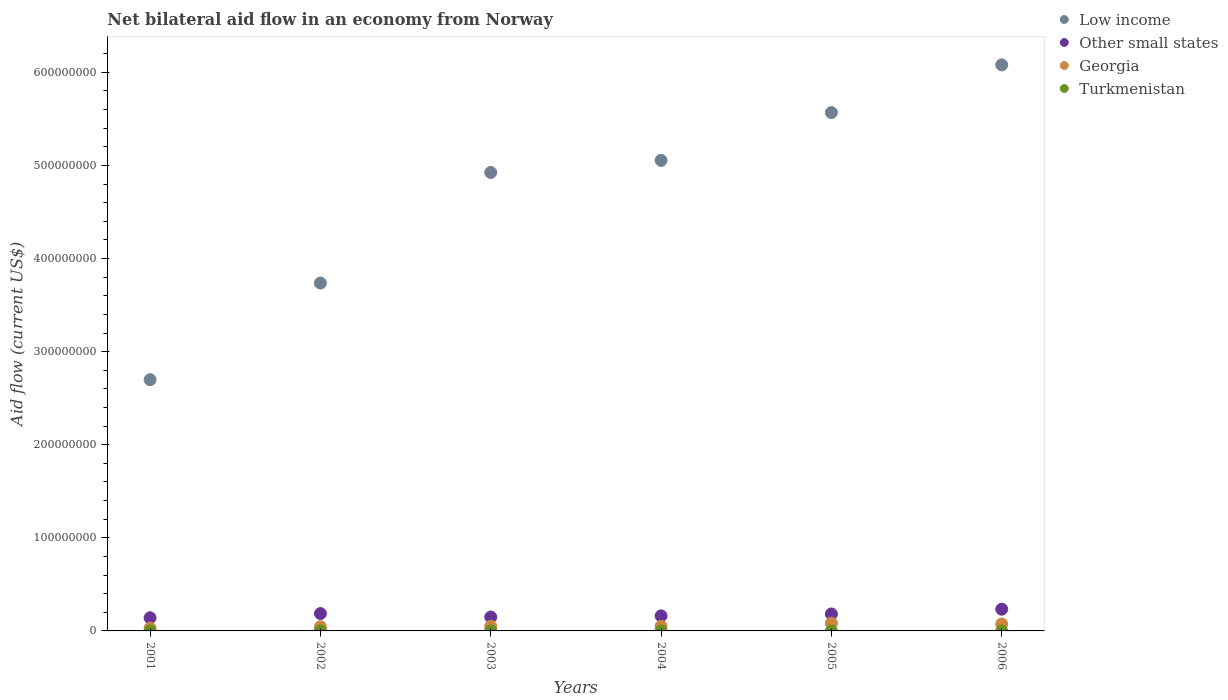How many different coloured dotlines are there?
Your response must be concise. 4. What is the net bilateral aid flow in Low income in 2001?
Provide a short and direct response. 2.70e+08. Across all years, what is the maximum net bilateral aid flow in Other small states?
Offer a very short reply. 2.33e+07. Across all years, what is the minimum net bilateral aid flow in Georgia?
Give a very brief answer. 3.11e+06. In which year was the net bilateral aid flow in Georgia maximum?
Your response must be concise. 2005. What is the total net bilateral aid flow in Georgia in the graph?
Your answer should be compact. 3.32e+07. What is the difference between the net bilateral aid flow in Georgia in 2001 and that in 2002?
Your answer should be very brief. -1.33e+06. What is the difference between the net bilateral aid flow in Other small states in 2002 and the net bilateral aid flow in Georgia in 2001?
Your response must be concise. 1.56e+07. What is the average net bilateral aid flow in Other small states per year?
Make the answer very short. 1.76e+07. In the year 2005, what is the difference between the net bilateral aid flow in Turkmenistan and net bilateral aid flow in Low income?
Your answer should be compact. -5.57e+08. What is the ratio of the net bilateral aid flow in Turkmenistan in 2001 to that in 2002?
Provide a short and direct response. 0.2. What is the difference between the highest and the second highest net bilateral aid flow in Low income?
Keep it short and to the point. 5.12e+07. What is the difference between the highest and the lowest net bilateral aid flow in Other small states?
Make the answer very short. 9.19e+06. Is the sum of the net bilateral aid flow in Georgia in 2004 and 2005 greater than the maximum net bilateral aid flow in Low income across all years?
Offer a terse response. No. Is it the case that in every year, the sum of the net bilateral aid flow in Georgia and net bilateral aid flow in Low income  is greater than the sum of net bilateral aid flow in Turkmenistan and net bilateral aid flow in Other small states?
Your answer should be compact. No. Does the net bilateral aid flow in Georgia monotonically increase over the years?
Give a very brief answer. No. Is the net bilateral aid flow in Georgia strictly less than the net bilateral aid flow in Low income over the years?
Provide a succinct answer. Yes. How many dotlines are there?
Provide a succinct answer. 4. How many years are there in the graph?
Keep it short and to the point. 6. Are the values on the major ticks of Y-axis written in scientific E-notation?
Give a very brief answer. No. Does the graph contain grids?
Provide a succinct answer. No. Where does the legend appear in the graph?
Your response must be concise. Top right. How many legend labels are there?
Offer a very short reply. 4. What is the title of the graph?
Keep it short and to the point. Net bilateral aid flow in an economy from Norway. Does "St. Vincent and the Grenadines" appear as one of the legend labels in the graph?
Offer a very short reply. No. What is the Aid flow (current US$) in Low income in 2001?
Offer a terse response. 2.70e+08. What is the Aid flow (current US$) in Other small states in 2001?
Provide a short and direct response. 1.41e+07. What is the Aid flow (current US$) in Georgia in 2001?
Ensure brevity in your answer.  3.11e+06. What is the Aid flow (current US$) in Low income in 2002?
Offer a terse response. 3.74e+08. What is the Aid flow (current US$) in Other small states in 2002?
Make the answer very short. 1.87e+07. What is the Aid flow (current US$) in Georgia in 2002?
Your answer should be compact. 4.44e+06. What is the Aid flow (current US$) of Low income in 2003?
Offer a terse response. 4.92e+08. What is the Aid flow (current US$) of Other small states in 2003?
Keep it short and to the point. 1.49e+07. What is the Aid flow (current US$) in Georgia in 2003?
Your response must be concise. 5.02e+06. What is the Aid flow (current US$) of Turkmenistan in 2003?
Ensure brevity in your answer.  1.40e+05. What is the Aid flow (current US$) in Low income in 2004?
Give a very brief answer. 5.05e+08. What is the Aid flow (current US$) in Other small states in 2004?
Give a very brief answer. 1.62e+07. What is the Aid flow (current US$) of Georgia in 2004?
Provide a succinct answer. 4.84e+06. What is the Aid flow (current US$) in Low income in 2005?
Your response must be concise. 5.57e+08. What is the Aid flow (current US$) of Other small states in 2005?
Keep it short and to the point. 1.82e+07. What is the Aid flow (current US$) in Georgia in 2005?
Give a very brief answer. 8.37e+06. What is the Aid flow (current US$) in Low income in 2006?
Keep it short and to the point. 6.08e+08. What is the Aid flow (current US$) in Other small states in 2006?
Offer a terse response. 2.33e+07. What is the Aid flow (current US$) of Georgia in 2006?
Your answer should be very brief. 7.42e+06. What is the Aid flow (current US$) of Turkmenistan in 2006?
Your answer should be very brief. 3.00e+04. Across all years, what is the maximum Aid flow (current US$) of Low income?
Keep it short and to the point. 6.08e+08. Across all years, what is the maximum Aid flow (current US$) in Other small states?
Your answer should be very brief. 2.33e+07. Across all years, what is the maximum Aid flow (current US$) of Georgia?
Your response must be concise. 8.37e+06. Across all years, what is the maximum Aid flow (current US$) in Turkmenistan?
Offer a very short reply. 2.00e+05. Across all years, what is the minimum Aid flow (current US$) of Low income?
Ensure brevity in your answer.  2.70e+08. Across all years, what is the minimum Aid flow (current US$) in Other small states?
Keep it short and to the point. 1.41e+07. Across all years, what is the minimum Aid flow (current US$) in Georgia?
Give a very brief answer. 3.11e+06. Across all years, what is the minimum Aid flow (current US$) of Turkmenistan?
Your answer should be very brief. 2.00e+04. What is the total Aid flow (current US$) in Low income in the graph?
Give a very brief answer. 2.81e+09. What is the total Aid flow (current US$) in Other small states in the graph?
Keep it short and to the point. 1.05e+08. What is the total Aid flow (current US$) in Georgia in the graph?
Your answer should be very brief. 3.32e+07. What is the total Aid flow (current US$) in Turkmenistan in the graph?
Your answer should be compact. 5.60e+05. What is the difference between the Aid flow (current US$) of Low income in 2001 and that in 2002?
Your answer should be compact. -1.04e+08. What is the difference between the Aid flow (current US$) of Other small states in 2001 and that in 2002?
Provide a short and direct response. -4.52e+06. What is the difference between the Aid flow (current US$) in Georgia in 2001 and that in 2002?
Your response must be concise. -1.33e+06. What is the difference between the Aid flow (current US$) of Turkmenistan in 2001 and that in 2002?
Offer a very short reply. -1.60e+05. What is the difference between the Aid flow (current US$) in Low income in 2001 and that in 2003?
Give a very brief answer. -2.23e+08. What is the difference between the Aid flow (current US$) in Other small states in 2001 and that in 2003?
Keep it short and to the point. -8.00e+05. What is the difference between the Aid flow (current US$) in Georgia in 2001 and that in 2003?
Offer a terse response. -1.91e+06. What is the difference between the Aid flow (current US$) in Low income in 2001 and that in 2004?
Offer a terse response. -2.36e+08. What is the difference between the Aid flow (current US$) in Other small states in 2001 and that in 2004?
Your answer should be very brief. -2.05e+06. What is the difference between the Aid flow (current US$) in Georgia in 2001 and that in 2004?
Give a very brief answer. -1.73e+06. What is the difference between the Aid flow (current US$) in Low income in 2001 and that in 2005?
Your response must be concise. -2.87e+08. What is the difference between the Aid flow (current US$) of Other small states in 2001 and that in 2005?
Ensure brevity in your answer.  -4.08e+06. What is the difference between the Aid flow (current US$) in Georgia in 2001 and that in 2005?
Your answer should be compact. -5.26e+06. What is the difference between the Aid flow (current US$) in Low income in 2001 and that in 2006?
Keep it short and to the point. -3.38e+08. What is the difference between the Aid flow (current US$) of Other small states in 2001 and that in 2006?
Give a very brief answer. -9.19e+06. What is the difference between the Aid flow (current US$) in Georgia in 2001 and that in 2006?
Your response must be concise. -4.31e+06. What is the difference between the Aid flow (current US$) in Turkmenistan in 2001 and that in 2006?
Keep it short and to the point. 10000. What is the difference between the Aid flow (current US$) of Low income in 2002 and that in 2003?
Your response must be concise. -1.19e+08. What is the difference between the Aid flow (current US$) in Other small states in 2002 and that in 2003?
Make the answer very short. 3.72e+06. What is the difference between the Aid flow (current US$) in Georgia in 2002 and that in 2003?
Ensure brevity in your answer.  -5.80e+05. What is the difference between the Aid flow (current US$) of Turkmenistan in 2002 and that in 2003?
Offer a very short reply. 6.00e+04. What is the difference between the Aid flow (current US$) of Low income in 2002 and that in 2004?
Your response must be concise. -1.32e+08. What is the difference between the Aid flow (current US$) in Other small states in 2002 and that in 2004?
Give a very brief answer. 2.47e+06. What is the difference between the Aid flow (current US$) of Georgia in 2002 and that in 2004?
Provide a short and direct response. -4.00e+05. What is the difference between the Aid flow (current US$) of Low income in 2002 and that in 2005?
Your answer should be very brief. -1.83e+08. What is the difference between the Aid flow (current US$) in Georgia in 2002 and that in 2005?
Offer a terse response. -3.93e+06. What is the difference between the Aid flow (current US$) of Turkmenistan in 2002 and that in 2005?
Your answer should be very brief. 1.80e+05. What is the difference between the Aid flow (current US$) of Low income in 2002 and that in 2006?
Your response must be concise. -2.34e+08. What is the difference between the Aid flow (current US$) of Other small states in 2002 and that in 2006?
Offer a very short reply. -4.67e+06. What is the difference between the Aid flow (current US$) of Georgia in 2002 and that in 2006?
Make the answer very short. -2.98e+06. What is the difference between the Aid flow (current US$) of Turkmenistan in 2002 and that in 2006?
Give a very brief answer. 1.70e+05. What is the difference between the Aid flow (current US$) in Low income in 2003 and that in 2004?
Your answer should be compact. -1.30e+07. What is the difference between the Aid flow (current US$) in Other small states in 2003 and that in 2004?
Give a very brief answer. -1.25e+06. What is the difference between the Aid flow (current US$) of Turkmenistan in 2003 and that in 2004?
Give a very brief answer. 10000. What is the difference between the Aid flow (current US$) of Low income in 2003 and that in 2005?
Offer a very short reply. -6.43e+07. What is the difference between the Aid flow (current US$) of Other small states in 2003 and that in 2005?
Keep it short and to the point. -3.28e+06. What is the difference between the Aid flow (current US$) of Georgia in 2003 and that in 2005?
Give a very brief answer. -3.35e+06. What is the difference between the Aid flow (current US$) of Low income in 2003 and that in 2006?
Offer a terse response. -1.16e+08. What is the difference between the Aid flow (current US$) of Other small states in 2003 and that in 2006?
Provide a short and direct response. -8.39e+06. What is the difference between the Aid flow (current US$) in Georgia in 2003 and that in 2006?
Ensure brevity in your answer.  -2.40e+06. What is the difference between the Aid flow (current US$) of Turkmenistan in 2003 and that in 2006?
Your response must be concise. 1.10e+05. What is the difference between the Aid flow (current US$) in Low income in 2004 and that in 2005?
Provide a succinct answer. -5.13e+07. What is the difference between the Aid flow (current US$) in Other small states in 2004 and that in 2005?
Your answer should be compact. -2.03e+06. What is the difference between the Aid flow (current US$) of Georgia in 2004 and that in 2005?
Give a very brief answer. -3.53e+06. What is the difference between the Aid flow (current US$) in Low income in 2004 and that in 2006?
Offer a terse response. -1.03e+08. What is the difference between the Aid flow (current US$) in Other small states in 2004 and that in 2006?
Your answer should be very brief. -7.14e+06. What is the difference between the Aid flow (current US$) in Georgia in 2004 and that in 2006?
Provide a succinct answer. -2.58e+06. What is the difference between the Aid flow (current US$) in Low income in 2005 and that in 2006?
Ensure brevity in your answer.  -5.12e+07. What is the difference between the Aid flow (current US$) of Other small states in 2005 and that in 2006?
Provide a succinct answer. -5.11e+06. What is the difference between the Aid flow (current US$) of Georgia in 2005 and that in 2006?
Offer a very short reply. 9.50e+05. What is the difference between the Aid flow (current US$) of Turkmenistan in 2005 and that in 2006?
Give a very brief answer. -10000. What is the difference between the Aid flow (current US$) of Low income in 2001 and the Aid flow (current US$) of Other small states in 2002?
Keep it short and to the point. 2.51e+08. What is the difference between the Aid flow (current US$) of Low income in 2001 and the Aid flow (current US$) of Georgia in 2002?
Make the answer very short. 2.65e+08. What is the difference between the Aid flow (current US$) of Low income in 2001 and the Aid flow (current US$) of Turkmenistan in 2002?
Offer a very short reply. 2.70e+08. What is the difference between the Aid flow (current US$) in Other small states in 2001 and the Aid flow (current US$) in Georgia in 2002?
Provide a succinct answer. 9.70e+06. What is the difference between the Aid flow (current US$) in Other small states in 2001 and the Aid flow (current US$) in Turkmenistan in 2002?
Give a very brief answer. 1.39e+07. What is the difference between the Aid flow (current US$) in Georgia in 2001 and the Aid flow (current US$) in Turkmenistan in 2002?
Your answer should be compact. 2.91e+06. What is the difference between the Aid flow (current US$) of Low income in 2001 and the Aid flow (current US$) of Other small states in 2003?
Ensure brevity in your answer.  2.55e+08. What is the difference between the Aid flow (current US$) of Low income in 2001 and the Aid flow (current US$) of Georgia in 2003?
Ensure brevity in your answer.  2.65e+08. What is the difference between the Aid flow (current US$) of Low income in 2001 and the Aid flow (current US$) of Turkmenistan in 2003?
Keep it short and to the point. 2.70e+08. What is the difference between the Aid flow (current US$) of Other small states in 2001 and the Aid flow (current US$) of Georgia in 2003?
Provide a short and direct response. 9.12e+06. What is the difference between the Aid flow (current US$) in Other small states in 2001 and the Aid flow (current US$) in Turkmenistan in 2003?
Your answer should be very brief. 1.40e+07. What is the difference between the Aid flow (current US$) of Georgia in 2001 and the Aid flow (current US$) of Turkmenistan in 2003?
Give a very brief answer. 2.97e+06. What is the difference between the Aid flow (current US$) in Low income in 2001 and the Aid flow (current US$) in Other small states in 2004?
Your answer should be compact. 2.54e+08. What is the difference between the Aid flow (current US$) in Low income in 2001 and the Aid flow (current US$) in Georgia in 2004?
Provide a short and direct response. 2.65e+08. What is the difference between the Aid flow (current US$) of Low income in 2001 and the Aid flow (current US$) of Turkmenistan in 2004?
Your response must be concise. 2.70e+08. What is the difference between the Aid flow (current US$) in Other small states in 2001 and the Aid flow (current US$) in Georgia in 2004?
Ensure brevity in your answer.  9.30e+06. What is the difference between the Aid flow (current US$) of Other small states in 2001 and the Aid flow (current US$) of Turkmenistan in 2004?
Ensure brevity in your answer.  1.40e+07. What is the difference between the Aid flow (current US$) of Georgia in 2001 and the Aid flow (current US$) of Turkmenistan in 2004?
Ensure brevity in your answer.  2.98e+06. What is the difference between the Aid flow (current US$) of Low income in 2001 and the Aid flow (current US$) of Other small states in 2005?
Provide a short and direct response. 2.52e+08. What is the difference between the Aid flow (current US$) of Low income in 2001 and the Aid flow (current US$) of Georgia in 2005?
Offer a terse response. 2.62e+08. What is the difference between the Aid flow (current US$) in Low income in 2001 and the Aid flow (current US$) in Turkmenistan in 2005?
Your response must be concise. 2.70e+08. What is the difference between the Aid flow (current US$) of Other small states in 2001 and the Aid flow (current US$) of Georgia in 2005?
Provide a short and direct response. 5.77e+06. What is the difference between the Aid flow (current US$) of Other small states in 2001 and the Aid flow (current US$) of Turkmenistan in 2005?
Your answer should be compact. 1.41e+07. What is the difference between the Aid flow (current US$) in Georgia in 2001 and the Aid flow (current US$) in Turkmenistan in 2005?
Make the answer very short. 3.09e+06. What is the difference between the Aid flow (current US$) in Low income in 2001 and the Aid flow (current US$) in Other small states in 2006?
Provide a succinct answer. 2.47e+08. What is the difference between the Aid flow (current US$) in Low income in 2001 and the Aid flow (current US$) in Georgia in 2006?
Provide a succinct answer. 2.62e+08. What is the difference between the Aid flow (current US$) in Low income in 2001 and the Aid flow (current US$) in Turkmenistan in 2006?
Ensure brevity in your answer.  2.70e+08. What is the difference between the Aid flow (current US$) in Other small states in 2001 and the Aid flow (current US$) in Georgia in 2006?
Your answer should be compact. 6.72e+06. What is the difference between the Aid flow (current US$) of Other small states in 2001 and the Aid flow (current US$) of Turkmenistan in 2006?
Your answer should be very brief. 1.41e+07. What is the difference between the Aid flow (current US$) of Georgia in 2001 and the Aid flow (current US$) of Turkmenistan in 2006?
Your response must be concise. 3.08e+06. What is the difference between the Aid flow (current US$) of Low income in 2002 and the Aid flow (current US$) of Other small states in 2003?
Your response must be concise. 3.59e+08. What is the difference between the Aid flow (current US$) in Low income in 2002 and the Aid flow (current US$) in Georgia in 2003?
Ensure brevity in your answer.  3.69e+08. What is the difference between the Aid flow (current US$) in Low income in 2002 and the Aid flow (current US$) in Turkmenistan in 2003?
Your answer should be very brief. 3.74e+08. What is the difference between the Aid flow (current US$) in Other small states in 2002 and the Aid flow (current US$) in Georgia in 2003?
Your answer should be very brief. 1.36e+07. What is the difference between the Aid flow (current US$) of Other small states in 2002 and the Aid flow (current US$) of Turkmenistan in 2003?
Provide a short and direct response. 1.85e+07. What is the difference between the Aid flow (current US$) in Georgia in 2002 and the Aid flow (current US$) in Turkmenistan in 2003?
Keep it short and to the point. 4.30e+06. What is the difference between the Aid flow (current US$) of Low income in 2002 and the Aid flow (current US$) of Other small states in 2004?
Offer a terse response. 3.57e+08. What is the difference between the Aid flow (current US$) in Low income in 2002 and the Aid flow (current US$) in Georgia in 2004?
Make the answer very short. 3.69e+08. What is the difference between the Aid flow (current US$) of Low income in 2002 and the Aid flow (current US$) of Turkmenistan in 2004?
Your response must be concise. 3.74e+08. What is the difference between the Aid flow (current US$) of Other small states in 2002 and the Aid flow (current US$) of Georgia in 2004?
Your answer should be compact. 1.38e+07. What is the difference between the Aid flow (current US$) of Other small states in 2002 and the Aid flow (current US$) of Turkmenistan in 2004?
Offer a terse response. 1.85e+07. What is the difference between the Aid flow (current US$) in Georgia in 2002 and the Aid flow (current US$) in Turkmenistan in 2004?
Your answer should be compact. 4.31e+06. What is the difference between the Aid flow (current US$) of Low income in 2002 and the Aid flow (current US$) of Other small states in 2005?
Offer a very short reply. 3.55e+08. What is the difference between the Aid flow (current US$) in Low income in 2002 and the Aid flow (current US$) in Georgia in 2005?
Your response must be concise. 3.65e+08. What is the difference between the Aid flow (current US$) of Low income in 2002 and the Aid flow (current US$) of Turkmenistan in 2005?
Your response must be concise. 3.74e+08. What is the difference between the Aid flow (current US$) in Other small states in 2002 and the Aid flow (current US$) in Georgia in 2005?
Give a very brief answer. 1.03e+07. What is the difference between the Aid flow (current US$) in Other small states in 2002 and the Aid flow (current US$) in Turkmenistan in 2005?
Make the answer very short. 1.86e+07. What is the difference between the Aid flow (current US$) in Georgia in 2002 and the Aid flow (current US$) in Turkmenistan in 2005?
Your answer should be very brief. 4.42e+06. What is the difference between the Aid flow (current US$) in Low income in 2002 and the Aid flow (current US$) in Other small states in 2006?
Make the answer very short. 3.50e+08. What is the difference between the Aid flow (current US$) of Low income in 2002 and the Aid flow (current US$) of Georgia in 2006?
Keep it short and to the point. 3.66e+08. What is the difference between the Aid flow (current US$) in Low income in 2002 and the Aid flow (current US$) in Turkmenistan in 2006?
Offer a terse response. 3.74e+08. What is the difference between the Aid flow (current US$) in Other small states in 2002 and the Aid flow (current US$) in Georgia in 2006?
Offer a terse response. 1.12e+07. What is the difference between the Aid flow (current US$) of Other small states in 2002 and the Aid flow (current US$) of Turkmenistan in 2006?
Your answer should be very brief. 1.86e+07. What is the difference between the Aid flow (current US$) of Georgia in 2002 and the Aid flow (current US$) of Turkmenistan in 2006?
Your answer should be very brief. 4.41e+06. What is the difference between the Aid flow (current US$) of Low income in 2003 and the Aid flow (current US$) of Other small states in 2004?
Ensure brevity in your answer.  4.76e+08. What is the difference between the Aid flow (current US$) of Low income in 2003 and the Aid flow (current US$) of Georgia in 2004?
Keep it short and to the point. 4.88e+08. What is the difference between the Aid flow (current US$) in Low income in 2003 and the Aid flow (current US$) in Turkmenistan in 2004?
Your answer should be very brief. 4.92e+08. What is the difference between the Aid flow (current US$) of Other small states in 2003 and the Aid flow (current US$) of Georgia in 2004?
Make the answer very short. 1.01e+07. What is the difference between the Aid flow (current US$) in Other small states in 2003 and the Aid flow (current US$) in Turkmenistan in 2004?
Offer a terse response. 1.48e+07. What is the difference between the Aid flow (current US$) of Georgia in 2003 and the Aid flow (current US$) of Turkmenistan in 2004?
Provide a short and direct response. 4.89e+06. What is the difference between the Aid flow (current US$) in Low income in 2003 and the Aid flow (current US$) in Other small states in 2005?
Your answer should be very brief. 4.74e+08. What is the difference between the Aid flow (current US$) in Low income in 2003 and the Aid flow (current US$) in Georgia in 2005?
Your answer should be compact. 4.84e+08. What is the difference between the Aid flow (current US$) in Low income in 2003 and the Aid flow (current US$) in Turkmenistan in 2005?
Your response must be concise. 4.92e+08. What is the difference between the Aid flow (current US$) of Other small states in 2003 and the Aid flow (current US$) of Georgia in 2005?
Ensure brevity in your answer.  6.57e+06. What is the difference between the Aid flow (current US$) in Other small states in 2003 and the Aid flow (current US$) in Turkmenistan in 2005?
Provide a short and direct response. 1.49e+07. What is the difference between the Aid flow (current US$) of Low income in 2003 and the Aid flow (current US$) of Other small states in 2006?
Give a very brief answer. 4.69e+08. What is the difference between the Aid flow (current US$) of Low income in 2003 and the Aid flow (current US$) of Georgia in 2006?
Keep it short and to the point. 4.85e+08. What is the difference between the Aid flow (current US$) in Low income in 2003 and the Aid flow (current US$) in Turkmenistan in 2006?
Your response must be concise. 4.92e+08. What is the difference between the Aid flow (current US$) in Other small states in 2003 and the Aid flow (current US$) in Georgia in 2006?
Your response must be concise. 7.52e+06. What is the difference between the Aid flow (current US$) in Other small states in 2003 and the Aid flow (current US$) in Turkmenistan in 2006?
Your response must be concise. 1.49e+07. What is the difference between the Aid flow (current US$) of Georgia in 2003 and the Aid flow (current US$) of Turkmenistan in 2006?
Make the answer very short. 4.99e+06. What is the difference between the Aid flow (current US$) of Low income in 2004 and the Aid flow (current US$) of Other small states in 2005?
Give a very brief answer. 4.87e+08. What is the difference between the Aid flow (current US$) of Low income in 2004 and the Aid flow (current US$) of Georgia in 2005?
Offer a terse response. 4.97e+08. What is the difference between the Aid flow (current US$) in Low income in 2004 and the Aid flow (current US$) in Turkmenistan in 2005?
Provide a succinct answer. 5.05e+08. What is the difference between the Aid flow (current US$) in Other small states in 2004 and the Aid flow (current US$) in Georgia in 2005?
Offer a very short reply. 7.82e+06. What is the difference between the Aid flow (current US$) in Other small states in 2004 and the Aid flow (current US$) in Turkmenistan in 2005?
Make the answer very short. 1.62e+07. What is the difference between the Aid flow (current US$) in Georgia in 2004 and the Aid flow (current US$) in Turkmenistan in 2005?
Your response must be concise. 4.82e+06. What is the difference between the Aid flow (current US$) in Low income in 2004 and the Aid flow (current US$) in Other small states in 2006?
Offer a terse response. 4.82e+08. What is the difference between the Aid flow (current US$) of Low income in 2004 and the Aid flow (current US$) of Georgia in 2006?
Your answer should be compact. 4.98e+08. What is the difference between the Aid flow (current US$) in Low income in 2004 and the Aid flow (current US$) in Turkmenistan in 2006?
Make the answer very short. 5.05e+08. What is the difference between the Aid flow (current US$) in Other small states in 2004 and the Aid flow (current US$) in Georgia in 2006?
Provide a succinct answer. 8.77e+06. What is the difference between the Aid flow (current US$) in Other small states in 2004 and the Aid flow (current US$) in Turkmenistan in 2006?
Keep it short and to the point. 1.62e+07. What is the difference between the Aid flow (current US$) in Georgia in 2004 and the Aid flow (current US$) in Turkmenistan in 2006?
Offer a terse response. 4.81e+06. What is the difference between the Aid flow (current US$) of Low income in 2005 and the Aid flow (current US$) of Other small states in 2006?
Your response must be concise. 5.33e+08. What is the difference between the Aid flow (current US$) in Low income in 2005 and the Aid flow (current US$) in Georgia in 2006?
Provide a short and direct response. 5.49e+08. What is the difference between the Aid flow (current US$) in Low income in 2005 and the Aid flow (current US$) in Turkmenistan in 2006?
Keep it short and to the point. 5.57e+08. What is the difference between the Aid flow (current US$) of Other small states in 2005 and the Aid flow (current US$) of Georgia in 2006?
Offer a very short reply. 1.08e+07. What is the difference between the Aid flow (current US$) of Other small states in 2005 and the Aid flow (current US$) of Turkmenistan in 2006?
Your answer should be compact. 1.82e+07. What is the difference between the Aid flow (current US$) of Georgia in 2005 and the Aid flow (current US$) of Turkmenistan in 2006?
Offer a very short reply. 8.34e+06. What is the average Aid flow (current US$) in Low income per year?
Make the answer very short. 4.68e+08. What is the average Aid flow (current US$) in Other small states per year?
Provide a succinct answer. 1.76e+07. What is the average Aid flow (current US$) of Georgia per year?
Your answer should be very brief. 5.53e+06. What is the average Aid flow (current US$) of Turkmenistan per year?
Give a very brief answer. 9.33e+04. In the year 2001, what is the difference between the Aid flow (current US$) of Low income and Aid flow (current US$) of Other small states?
Ensure brevity in your answer.  2.56e+08. In the year 2001, what is the difference between the Aid flow (current US$) in Low income and Aid flow (current US$) in Georgia?
Provide a succinct answer. 2.67e+08. In the year 2001, what is the difference between the Aid flow (current US$) in Low income and Aid flow (current US$) in Turkmenistan?
Offer a terse response. 2.70e+08. In the year 2001, what is the difference between the Aid flow (current US$) of Other small states and Aid flow (current US$) of Georgia?
Make the answer very short. 1.10e+07. In the year 2001, what is the difference between the Aid flow (current US$) of Other small states and Aid flow (current US$) of Turkmenistan?
Provide a succinct answer. 1.41e+07. In the year 2001, what is the difference between the Aid flow (current US$) in Georgia and Aid flow (current US$) in Turkmenistan?
Your answer should be very brief. 3.07e+06. In the year 2002, what is the difference between the Aid flow (current US$) of Low income and Aid flow (current US$) of Other small states?
Give a very brief answer. 3.55e+08. In the year 2002, what is the difference between the Aid flow (current US$) of Low income and Aid flow (current US$) of Georgia?
Offer a terse response. 3.69e+08. In the year 2002, what is the difference between the Aid flow (current US$) in Low income and Aid flow (current US$) in Turkmenistan?
Ensure brevity in your answer.  3.73e+08. In the year 2002, what is the difference between the Aid flow (current US$) of Other small states and Aid flow (current US$) of Georgia?
Offer a terse response. 1.42e+07. In the year 2002, what is the difference between the Aid flow (current US$) in Other small states and Aid flow (current US$) in Turkmenistan?
Offer a terse response. 1.85e+07. In the year 2002, what is the difference between the Aid flow (current US$) in Georgia and Aid flow (current US$) in Turkmenistan?
Offer a very short reply. 4.24e+06. In the year 2003, what is the difference between the Aid flow (current US$) in Low income and Aid flow (current US$) in Other small states?
Offer a terse response. 4.78e+08. In the year 2003, what is the difference between the Aid flow (current US$) in Low income and Aid flow (current US$) in Georgia?
Offer a very short reply. 4.87e+08. In the year 2003, what is the difference between the Aid flow (current US$) in Low income and Aid flow (current US$) in Turkmenistan?
Make the answer very short. 4.92e+08. In the year 2003, what is the difference between the Aid flow (current US$) in Other small states and Aid flow (current US$) in Georgia?
Your response must be concise. 9.92e+06. In the year 2003, what is the difference between the Aid flow (current US$) in Other small states and Aid flow (current US$) in Turkmenistan?
Ensure brevity in your answer.  1.48e+07. In the year 2003, what is the difference between the Aid flow (current US$) in Georgia and Aid flow (current US$) in Turkmenistan?
Give a very brief answer. 4.88e+06. In the year 2004, what is the difference between the Aid flow (current US$) in Low income and Aid flow (current US$) in Other small states?
Give a very brief answer. 4.89e+08. In the year 2004, what is the difference between the Aid flow (current US$) of Low income and Aid flow (current US$) of Georgia?
Provide a succinct answer. 5.01e+08. In the year 2004, what is the difference between the Aid flow (current US$) in Low income and Aid flow (current US$) in Turkmenistan?
Your answer should be compact. 5.05e+08. In the year 2004, what is the difference between the Aid flow (current US$) in Other small states and Aid flow (current US$) in Georgia?
Keep it short and to the point. 1.14e+07. In the year 2004, what is the difference between the Aid flow (current US$) in Other small states and Aid flow (current US$) in Turkmenistan?
Your response must be concise. 1.61e+07. In the year 2004, what is the difference between the Aid flow (current US$) in Georgia and Aid flow (current US$) in Turkmenistan?
Make the answer very short. 4.71e+06. In the year 2005, what is the difference between the Aid flow (current US$) in Low income and Aid flow (current US$) in Other small states?
Your answer should be very brief. 5.39e+08. In the year 2005, what is the difference between the Aid flow (current US$) of Low income and Aid flow (current US$) of Georgia?
Ensure brevity in your answer.  5.48e+08. In the year 2005, what is the difference between the Aid flow (current US$) in Low income and Aid flow (current US$) in Turkmenistan?
Keep it short and to the point. 5.57e+08. In the year 2005, what is the difference between the Aid flow (current US$) of Other small states and Aid flow (current US$) of Georgia?
Ensure brevity in your answer.  9.85e+06. In the year 2005, what is the difference between the Aid flow (current US$) in Other small states and Aid flow (current US$) in Turkmenistan?
Offer a terse response. 1.82e+07. In the year 2005, what is the difference between the Aid flow (current US$) in Georgia and Aid flow (current US$) in Turkmenistan?
Ensure brevity in your answer.  8.35e+06. In the year 2006, what is the difference between the Aid flow (current US$) in Low income and Aid flow (current US$) in Other small states?
Provide a short and direct response. 5.85e+08. In the year 2006, what is the difference between the Aid flow (current US$) of Low income and Aid flow (current US$) of Georgia?
Your answer should be compact. 6.01e+08. In the year 2006, what is the difference between the Aid flow (current US$) in Low income and Aid flow (current US$) in Turkmenistan?
Make the answer very short. 6.08e+08. In the year 2006, what is the difference between the Aid flow (current US$) in Other small states and Aid flow (current US$) in Georgia?
Provide a succinct answer. 1.59e+07. In the year 2006, what is the difference between the Aid flow (current US$) of Other small states and Aid flow (current US$) of Turkmenistan?
Your answer should be compact. 2.33e+07. In the year 2006, what is the difference between the Aid flow (current US$) in Georgia and Aid flow (current US$) in Turkmenistan?
Provide a short and direct response. 7.39e+06. What is the ratio of the Aid flow (current US$) of Low income in 2001 to that in 2002?
Give a very brief answer. 0.72. What is the ratio of the Aid flow (current US$) of Other small states in 2001 to that in 2002?
Give a very brief answer. 0.76. What is the ratio of the Aid flow (current US$) of Georgia in 2001 to that in 2002?
Your answer should be very brief. 0.7. What is the ratio of the Aid flow (current US$) in Turkmenistan in 2001 to that in 2002?
Offer a very short reply. 0.2. What is the ratio of the Aid flow (current US$) in Low income in 2001 to that in 2003?
Ensure brevity in your answer.  0.55. What is the ratio of the Aid flow (current US$) of Other small states in 2001 to that in 2003?
Provide a succinct answer. 0.95. What is the ratio of the Aid flow (current US$) of Georgia in 2001 to that in 2003?
Keep it short and to the point. 0.62. What is the ratio of the Aid flow (current US$) in Turkmenistan in 2001 to that in 2003?
Ensure brevity in your answer.  0.29. What is the ratio of the Aid flow (current US$) in Low income in 2001 to that in 2004?
Make the answer very short. 0.53. What is the ratio of the Aid flow (current US$) in Other small states in 2001 to that in 2004?
Provide a succinct answer. 0.87. What is the ratio of the Aid flow (current US$) in Georgia in 2001 to that in 2004?
Your answer should be compact. 0.64. What is the ratio of the Aid flow (current US$) of Turkmenistan in 2001 to that in 2004?
Make the answer very short. 0.31. What is the ratio of the Aid flow (current US$) in Low income in 2001 to that in 2005?
Provide a short and direct response. 0.48. What is the ratio of the Aid flow (current US$) of Other small states in 2001 to that in 2005?
Provide a succinct answer. 0.78. What is the ratio of the Aid flow (current US$) of Georgia in 2001 to that in 2005?
Give a very brief answer. 0.37. What is the ratio of the Aid flow (current US$) in Turkmenistan in 2001 to that in 2005?
Your response must be concise. 2. What is the ratio of the Aid flow (current US$) in Low income in 2001 to that in 2006?
Your answer should be compact. 0.44. What is the ratio of the Aid flow (current US$) in Other small states in 2001 to that in 2006?
Offer a very short reply. 0.61. What is the ratio of the Aid flow (current US$) in Georgia in 2001 to that in 2006?
Your response must be concise. 0.42. What is the ratio of the Aid flow (current US$) in Turkmenistan in 2001 to that in 2006?
Your answer should be compact. 1.33. What is the ratio of the Aid flow (current US$) in Low income in 2002 to that in 2003?
Offer a very short reply. 0.76. What is the ratio of the Aid flow (current US$) of Other small states in 2002 to that in 2003?
Make the answer very short. 1.25. What is the ratio of the Aid flow (current US$) of Georgia in 2002 to that in 2003?
Give a very brief answer. 0.88. What is the ratio of the Aid flow (current US$) of Turkmenistan in 2002 to that in 2003?
Your answer should be compact. 1.43. What is the ratio of the Aid flow (current US$) of Low income in 2002 to that in 2004?
Ensure brevity in your answer.  0.74. What is the ratio of the Aid flow (current US$) of Other small states in 2002 to that in 2004?
Offer a terse response. 1.15. What is the ratio of the Aid flow (current US$) of Georgia in 2002 to that in 2004?
Provide a short and direct response. 0.92. What is the ratio of the Aid flow (current US$) of Turkmenistan in 2002 to that in 2004?
Keep it short and to the point. 1.54. What is the ratio of the Aid flow (current US$) of Low income in 2002 to that in 2005?
Make the answer very short. 0.67. What is the ratio of the Aid flow (current US$) in Other small states in 2002 to that in 2005?
Keep it short and to the point. 1.02. What is the ratio of the Aid flow (current US$) of Georgia in 2002 to that in 2005?
Your response must be concise. 0.53. What is the ratio of the Aid flow (current US$) of Turkmenistan in 2002 to that in 2005?
Your answer should be compact. 10. What is the ratio of the Aid flow (current US$) in Low income in 2002 to that in 2006?
Offer a very short reply. 0.61. What is the ratio of the Aid flow (current US$) of Other small states in 2002 to that in 2006?
Provide a succinct answer. 0.8. What is the ratio of the Aid flow (current US$) in Georgia in 2002 to that in 2006?
Make the answer very short. 0.6. What is the ratio of the Aid flow (current US$) of Low income in 2003 to that in 2004?
Keep it short and to the point. 0.97. What is the ratio of the Aid flow (current US$) in Other small states in 2003 to that in 2004?
Your response must be concise. 0.92. What is the ratio of the Aid flow (current US$) of Georgia in 2003 to that in 2004?
Ensure brevity in your answer.  1.04. What is the ratio of the Aid flow (current US$) in Turkmenistan in 2003 to that in 2004?
Provide a short and direct response. 1.08. What is the ratio of the Aid flow (current US$) in Low income in 2003 to that in 2005?
Your response must be concise. 0.88. What is the ratio of the Aid flow (current US$) of Other small states in 2003 to that in 2005?
Ensure brevity in your answer.  0.82. What is the ratio of the Aid flow (current US$) of Georgia in 2003 to that in 2005?
Ensure brevity in your answer.  0.6. What is the ratio of the Aid flow (current US$) in Turkmenistan in 2003 to that in 2005?
Ensure brevity in your answer.  7. What is the ratio of the Aid flow (current US$) of Low income in 2003 to that in 2006?
Make the answer very short. 0.81. What is the ratio of the Aid flow (current US$) in Other small states in 2003 to that in 2006?
Your answer should be compact. 0.64. What is the ratio of the Aid flow (current US$) in Georgia in 2003 to that in 2006?
Provide a short and direct response. 0.68. What is the ratio of the Aid flow (current US$) of Turkmenistan in 2003 to that in 2006?
Give a very brief answer. 4.67. What is the ratio of the Aid flow (current US$) in Low income in 2004 to that in 2005?
Offer a terse response. 0.91. What is the ratio of the Aid flow (current US$) in Other small states in 2004 to that in 2005?
Make the answer very short. 0.89. What is the ratio of the Aid flow (current US$) in Georgia in 2004 to that in 2005?
Provide a succinct answer. 0.58. What is the ratio of the Aid flow (current US$) in Low income in 2004 to that in 2006?
Keep it short and to the point. 0.83. What is the ratio of the Aid flow (current US$) in Other small states in 2004 to that in 2006?
Make the answer very short. 0.69. What is the ratio of the Aid flow (current US$) of Georgia in 2004 to that in 2006?
Provide a succinct answer. 0.65. What is the ratio of the Aid flow (current US$) of Turkmenistan in 2004 to that in 2006?
Offer a terse response. 4.33. What is the ratio of the Aid flow (current US$) in Low income in 2005 to that in 2006?
Your answer should be compact. 0.92. What is the ratio of the Aid flow (current US$) of Other small states in 2005 to that in 2006?
Ensure brevity in your answer.  0.78. What is the ratio of the Aid flow (current US$) of Georgia in 2005 to that in 2006?
Offer a very short reply. 1.13. What is the ratio of the Aid flow (current US$) in Turkmenistan in 2005 to that in 2006?
Provide a succinct answer. 0.67. What is the difference between the highest and the second highest Aid flow (current US$) of Low income?
Provide a short and direct response. 5.12e+07. What is the difference between the highest and the second highest Aid flow (current US$) in Other small states?
Make the answer very short. 4.67e+06. What is the difference between the highest and the second highest Aid flow (current US$) of Georgia?
Provide a short and direct response. 9.50e+05. What is the difference between the highest and the lowest Aid flow (current US$) of Low income?
Your answer should be compact. 3.38e+08. What is the difference between the highest and the lowest Aid flow (current US$) in Other small states?
Your answer should be very brief. 9.19e+06. What is the difference between the highest and the lowest Aid flow (current US$) in Georgia?
Provide a succinct answer. 5.26e+06. 